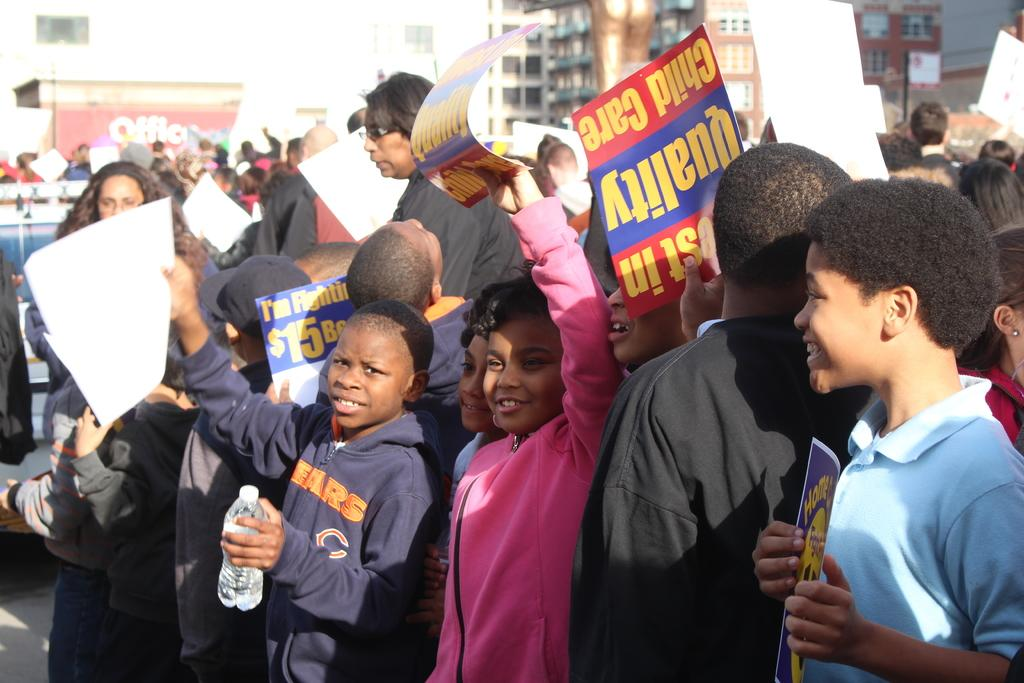Who is present in the image? There are kids in the image. What are the kids wearing? The kids are wearing clothes. What are the kids holding in the image? The kids are holding placards. What can be seen in the background of the image? There is a building at the top of the image. What type of discovery can be seen in the image? There is no discovery present in the image; it features kids holding placards. What tool is being used to crush something in the image? There is no tool or crushing activity present in the image. 